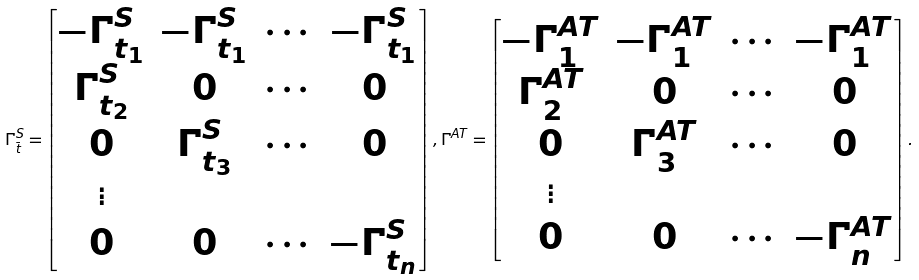Convert formula to latex. <formula><loc_0><loc_0><loc_500><loc_500>\Gamma ^ { S } _ { \bar { t } } = \begin{bmatrix} - \Gamma ^ { S } _ { t _ { 1 } } & - \Gamma ^ { S } _ { t _ { 1 } } & \cdots & - \Gamma ^ { S } _ { t _ { 1 } } \\ \Gamma ^ { S } _ { t _ { 2 } } & 0 & \cdots & 0 \\ 0 & \Gamma ^ { S } _ { t _ { 3 } } & \cdots & 0 \\ \vdots & & & \\ 0 & 0 & \cdots & - \Gamma ^ { S } _ { t _ { n } } \end{bmatrix} , \Gamma ^ { A T } = \begin{bmatrix} - \Gamma ^ { A T } _ { 1 } & - \Gamma ^ { A T } _ { 1 } & \cdots & - \Gamma ^ { A T } _ { 1 } \\ \Gamma ^ { A T } _ { 2 } & 0 & \cdots & 0 \\ 0 & \Gamma ^ { A T } _ { 3 } & \cdots & 0 \\ \vdots & & & \\ 0 & 0 & \cdots & - \Gamma ^ { A T } _ { n } \end{bmatrix} .</formula> 